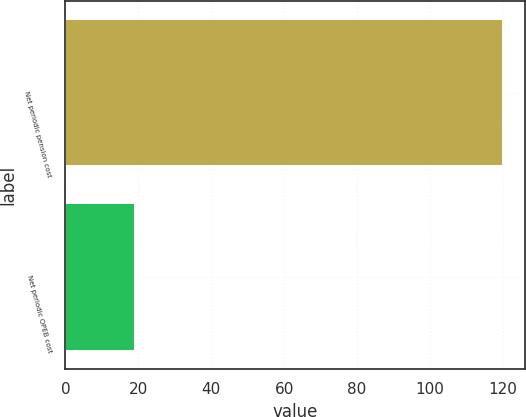Convert chart. <chart><loc_0><loc_0><loc_500><loc_500><bar_chart><fcel>Net periodic pension cost<fcel>Net periodic OPEB cost<nl><fcel>120<fcel>19<nl></chart> 